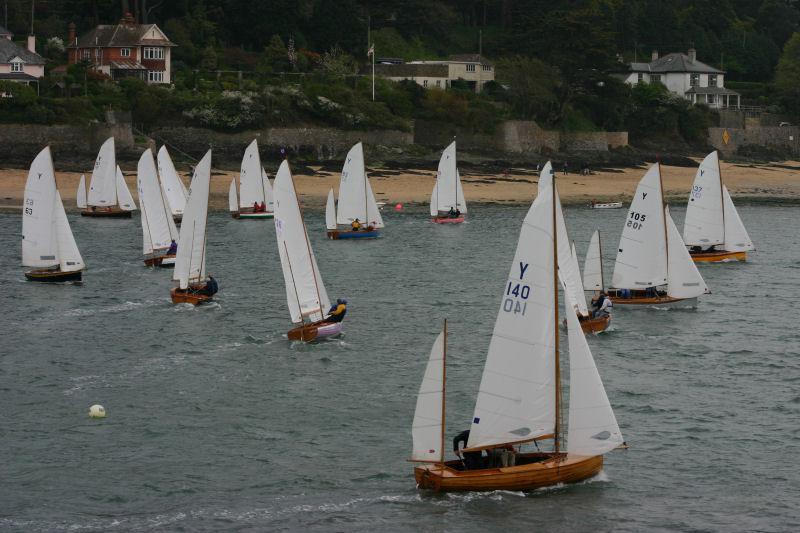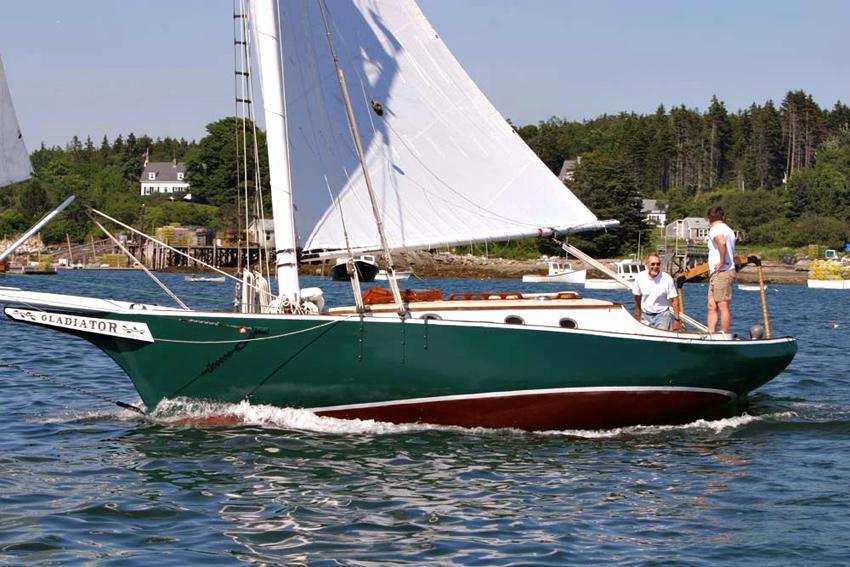The first image is the image on the left, the second image is the image on the right. Examine the images to the left and right. Is the description "in at least one image there is a single  boat with 3 sails" accurate? Answer yes or no. No. The first image is the image on the left, the second image is the image on the right. For the images shown, is this caption "There is a single boat on the water with exactly 3 white sails open, that are being used to move the boat." true? Answer yes or no. No. 